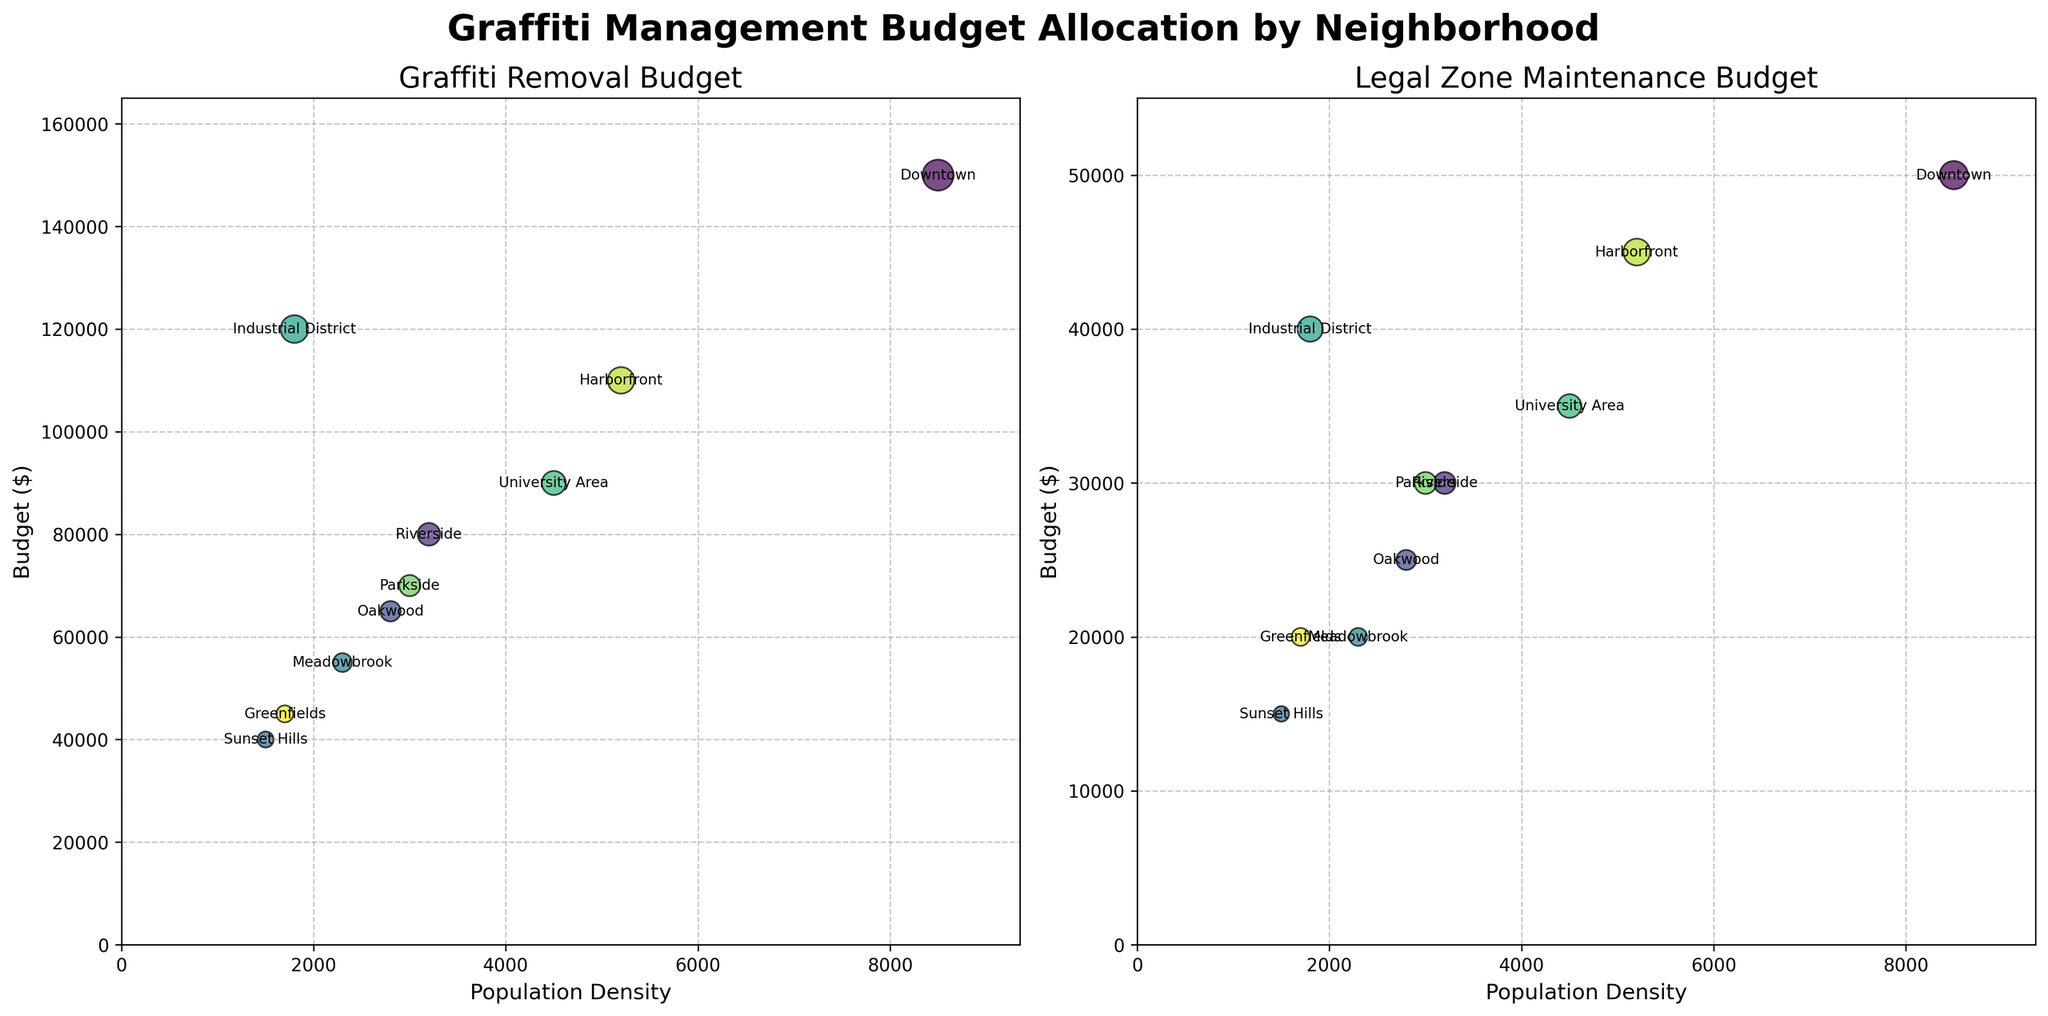What's the title of the figure? The title is located at the top center of the figure and is often larger and bolder than other text to indicate its importance.
Answer: Graffiti Management Budget Allocation by Neighborhood What are the titles of the two subplots? The titles of the subplots can be found just above each subplot and describe the main focus of each chart.
Answer: Graffiti Removal Budget, Legal Zone Maintenance Budget Which neighborhood has the highest Graffiti Removal Budget? By looking at the vertical positions of the bubbles in the left subplot, the highest positioned bubble represents the largest budget. In this case, Downtown is at the top.
Answer: Downtown Which neighborhood has the lowest population density? The lowest population density is shown on the x-axis, where the bubble farthest to the left indicates the smallest value. Greenfields is the bubble in the far-left position.
Answer: Greenfields Is there any neighborhood with the same budget for both Graffiti Removal and Legal Zone Maintenance? Each neighborhood's position on both axes must be compared to check if the Graffiti Removal Budget value equals the Legal Zone Maintenance Budget value. No bubbles in both charts share the same y-value for their respective neighborhood.
Answer: No What’s the average Graffiti Removal Budget across all neighborhoods? Sum all Graffiti Removal Budget values and divide by the number of neighborhoods: (150000 + 80000 + 65000 + 40000 + 55000 + 120000 + 90000 + 70000 + 110000 + 45000) / 10.
Answer: 77500 Which neighborhood has the highest Legal Zone Maintenance Budget relative to its population density? To determine this, look for the highest vertical position (budget) relative to its horizontal position (population density) in the right subplot. Downtown has both high population density and high budget but there are others like Harborfront that maintain a comparable budget within a smaller population density range.
Answer: Harborfront How much more of the Graffiti Removal Budget does Downtown have compared to Riverside? Subtract Riverside's budget from Downtown's budget: 150000 - 80000.
Answer: 70000 Which neighborhood has a higher budget for Legal Zone Maintenance than for Graffiti Removal? To identify neighborhoods with a smaller bubble on the left plot (representing Graffiti Removal) and bigger on the right plot (representing Legal Zone Maintenance), quickly scanning both plots identifies no such condition.
Answer: None What’s the total Legal Zone Maintenance Budget for all neighborhoods? Summing all of the Legal Zone Maintenance Budgets: 50000 + 30000 + 25000 + 15000 + 20000 + 40000 + 35000 + 30000 + 45000 + 20000.
Answer: 310000 